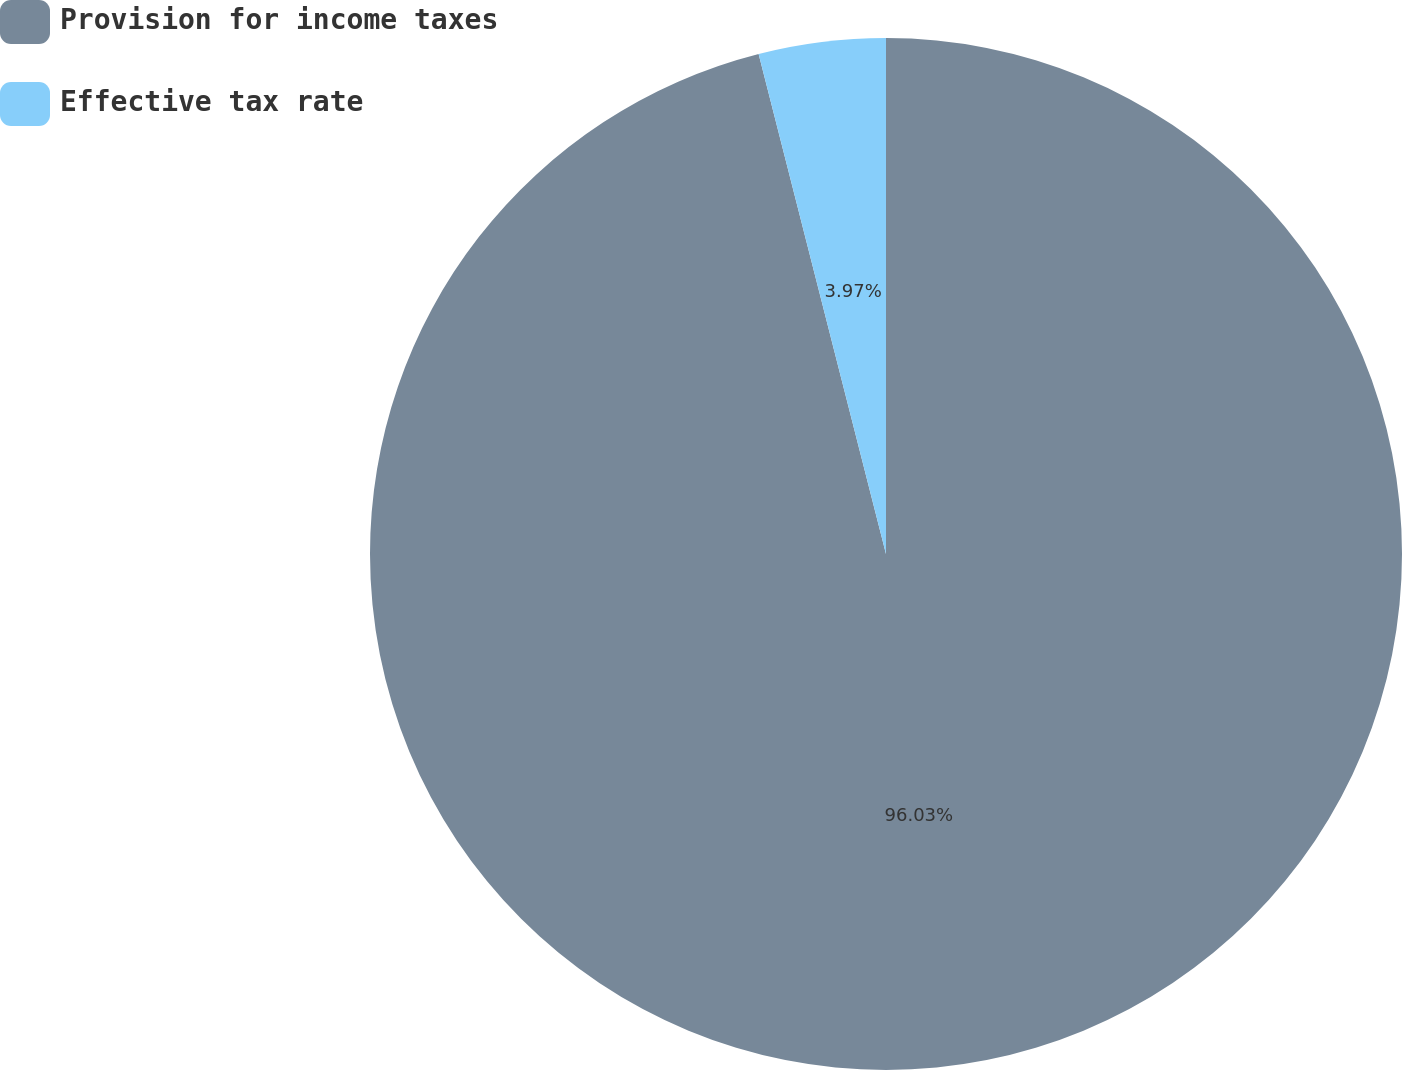Convert chart to OTSL. <chart><loc_0><loc_0><loc_500><loc_500><pie_chart><fcel>Provision for income taxes<fcel>Effective tax rate<nl><fcel>96.03%<fcel>3.97%<nl></chart> 